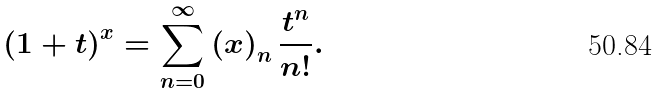Convert formula to latex. <formula><loc_0><loc_0><loc_500><loc_500>\left ( 1 + t \right ) ^ { x } = \sum _ { n = 0 } ^ { \infty } \left ( x \right ) _ { n } \frac { t ^ { n } } { n ! } .</formula> 